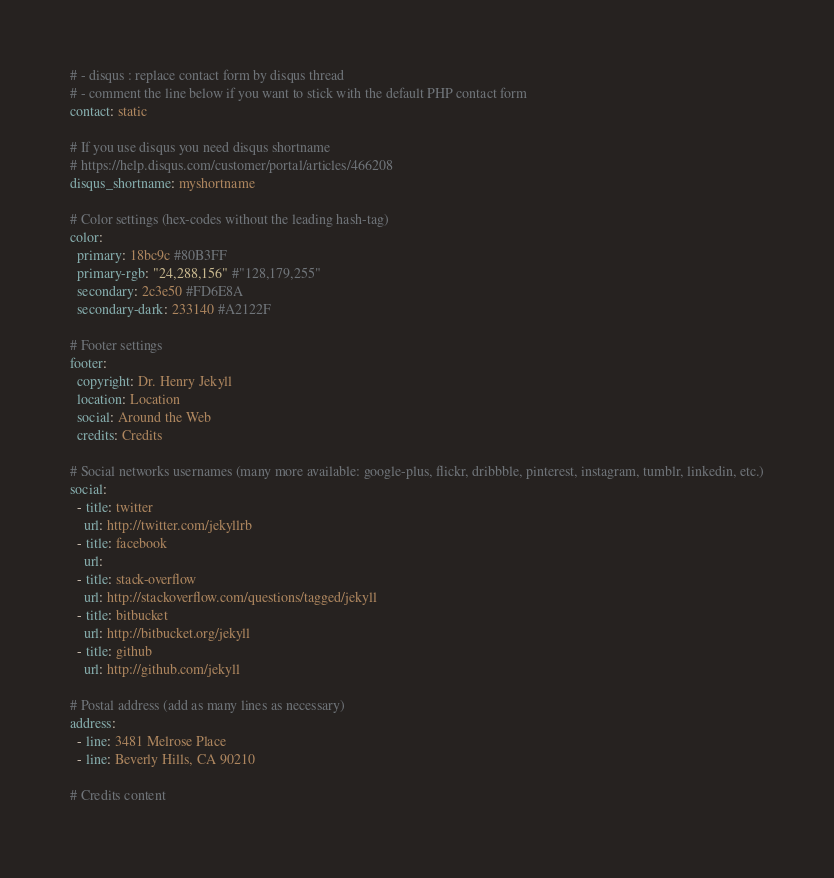<code> <loc_0><loc_0><loc_500><loc_500><_YAML_># - disqus : replace contact form by disqus thread
# - comment the line below if you want to stick with the default PHP contact form
contact: static

# If you use disqus you need disqus shortname
# https://help.disqus.com/customer/portal/articles/466208
disqus_shortname: myshortname

# Color settings (hex-codes without the leading hash-tag)
color:
  primary: 18bc9c #80B3FF
  primary-rgb: "24,288,156" #"128,179,255"
  secondary: 2c3e50 #FD6E8A
  secondary-dark: 233140 #A2122F

# Footer settings
footer:
  copyright: Dr. Henry Jekyll
  location: Location
  social: Around the Web
  credits: Credits

# Social networks usernames (many more available: google-plus, flickr, dribbble, pinterest, instagram, tumblr, linkedin, etc.)
social:
  - title: twitter
    url: http://twitter.com/jekyllrb
  - title: facebook
    url:
  - title: stack-overflow
    url: http://stackoverflow.com/questions/tagged/jekyll
  - title: bitbucket
    url: http://bitbucket.org/jekyll
  - title: github
    url: http://github.com/jekyll

# Postal address (add as many lines as necessary)
address:
  - line: 3481 Melrose Place
  - line: Beverly Hills, CA 90210

# Credits content</code> 